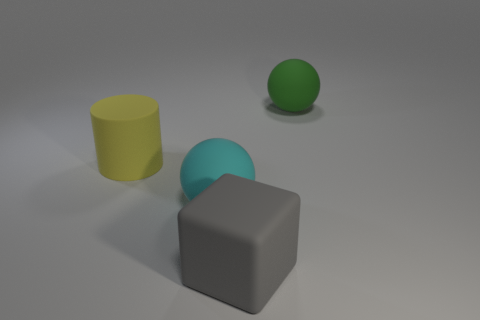There is a matte cylinder; does it have the same color as the sphere that is left of the large green matte sphere?
Your answer should be compact. No. The rubber block has what color?
Give a very brief answer. Gray. How many things are either small cylinders or yellow matte cylinders?
Offer a very short reply. 1. There is a cyan sphere that is the same size as the cylinder; what material is it?
Your answer should be very brief. Rubber. There is a sphere that is in front of the green rubber sphere; how big is it?
Your answer should be compact. Large. What is the material of the cyan object?
Make the answer very short. Rubber. What number of things are either matte spheres that are behind the yellow object or objects in front of the big green rubber ball?
Keep it short and to the point. 4. What number of other things are there of the same color as the large block?
Make the answer very short. 0. There is a green object; is it the same shape as the object on the left side of the cyan rubber sphere?
Give a very brief answer. No. Is the number of balls that are behind the cylinder less than the number of large cyan matte balls behind the big green rubber object?
Your answer should be very brief. No. 